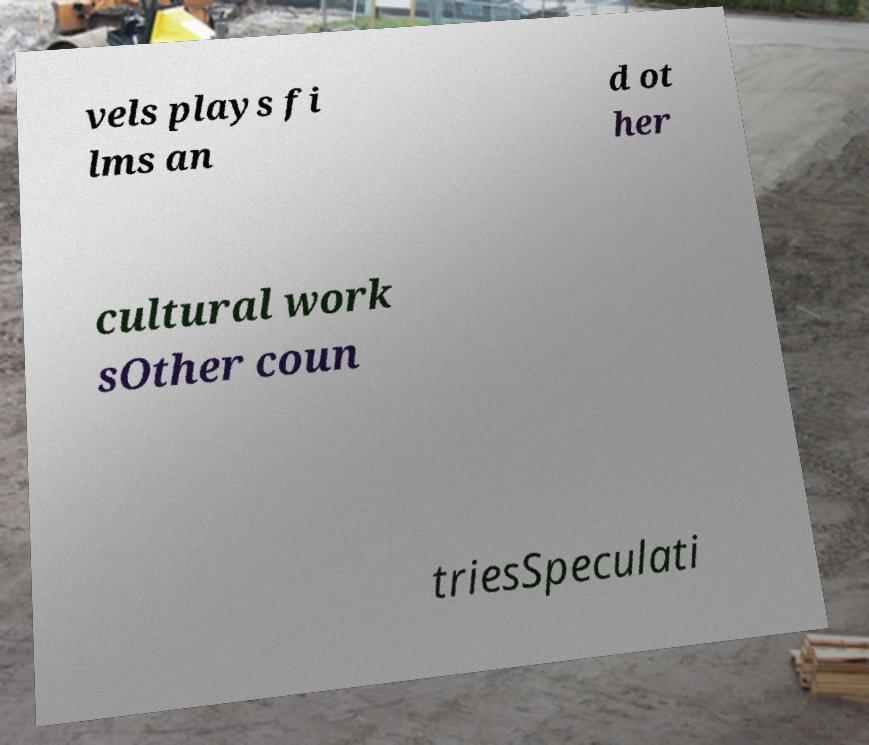There's text embedded in this image that I need extracted. Can you transcribe it verbatim? vels plays fi lms an d ot her cultural work sOther coun triesSpeculati 